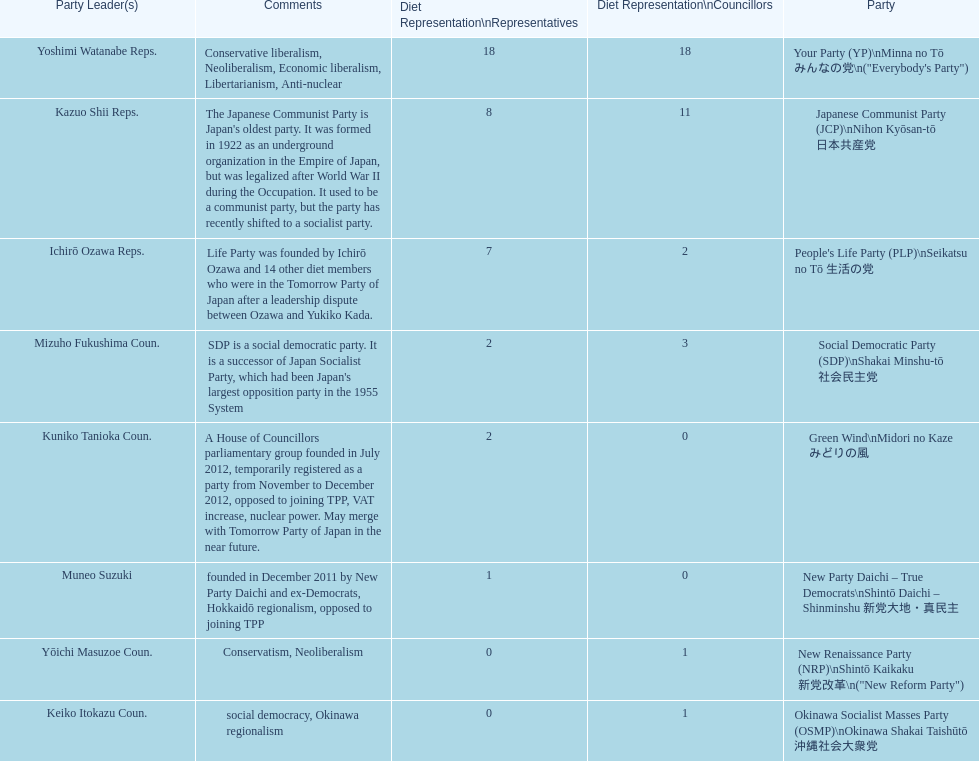According to this table, which party is japan's oldest political party? Japanese Communist Party (JCP) Nihon Kyōsan-tō 日本共産党. 